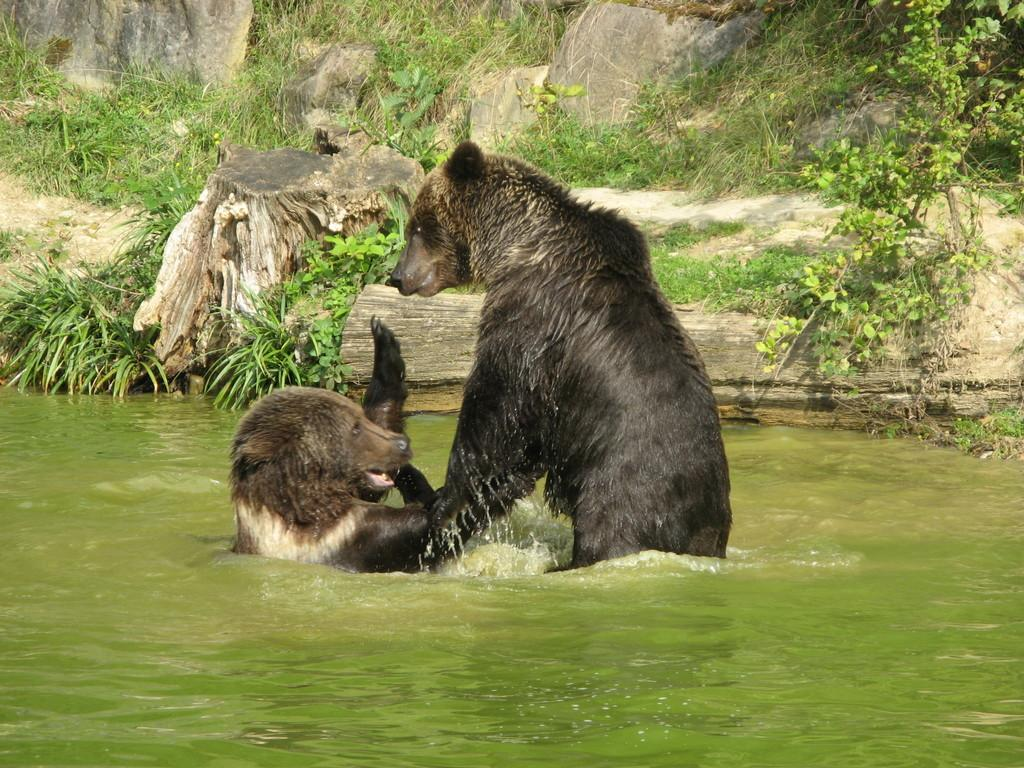Where was the picture taken? The picture was taken outside. What is the main subject in the center of the image? There are animals in a water body in the center of the image. What can be seen in the background of the image? There are rocks, green grass, and plants visible in the background of the image. What type of appliance can be seen in the water body with the animals? There is no appliance present in the water body with the animals; it is a natural scene with animals and a water body. 